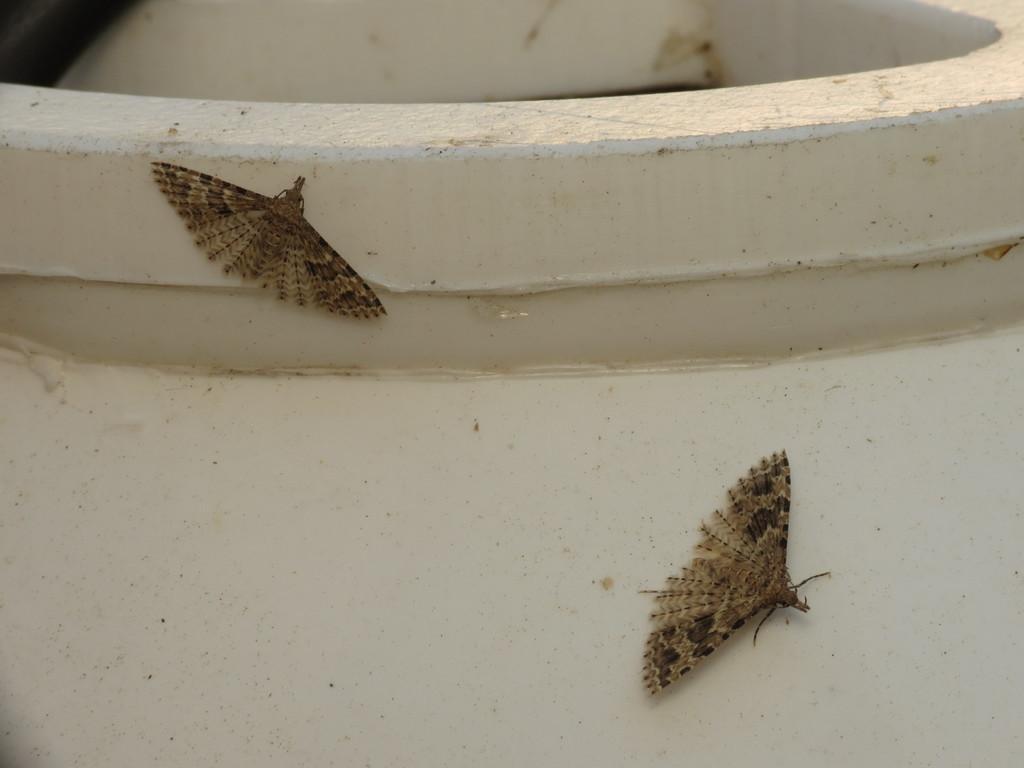Can you describe this image briefly? Here we can see two brown house moths on a big pot. 